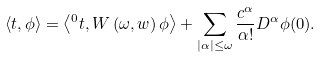<formula> <loc_0><loc_0><loc_500><loc_500>\left \langle t , \phi \right \rangle = \left \langle { ^ { 0 } t } , W \left ( \omega , w \right ) \phi \right \rangle + \sum _ { | \alpha | \leq \omega } \frac { c ^ { \alpha } } { \alpha ! } D ^ { \alpha } \phi ( 0 ) .</formula> 